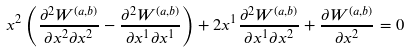Convert formula to latex. <formula><loc_0><loc_0><loc_500><loc_500>x ^ { 2 } \left ( \frac { \partial ^ { 2 } W ^ { ( a , b ) } } { \partial x ^ { 2 } \partial x ^ { 2 } } - \frac { \partial ^ { 2 } W ^ { ( a , b ) } } { \partial x ^ { 1 } \partial x ^ { 1 } } \right ) + 2 x ^ { 1 } \frac { \partial ^ { 2 } W ^ { ( a , b ) } } { \partial x ^ { 1 } \partial x ^ { 2 } } + \frac { \partial W ^ { ( a , b ) } } { \partial x ^ { 2 } } = 0</formula> 